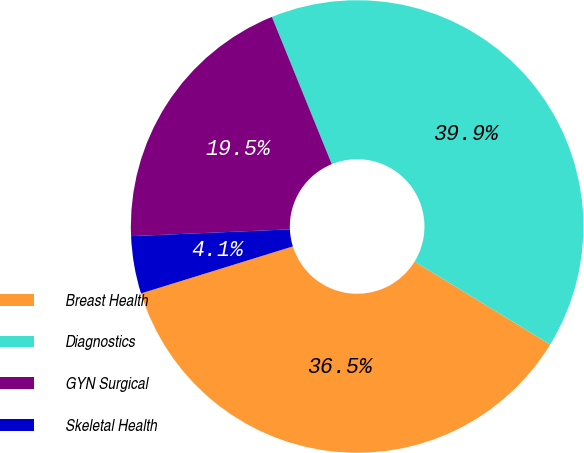Convert chart to OTSL. <chart><loc_0><loc_0><loc_500><loc_500><pie_chart><fcel>Breast Health<fcel>Diagnostics<fcel>GYN Surgical<fcel>Skeletal Health<nl><fcel>36.48%<fcel>39.88%<fcel>19.53%<fcel>4.1%<nl></chart> 